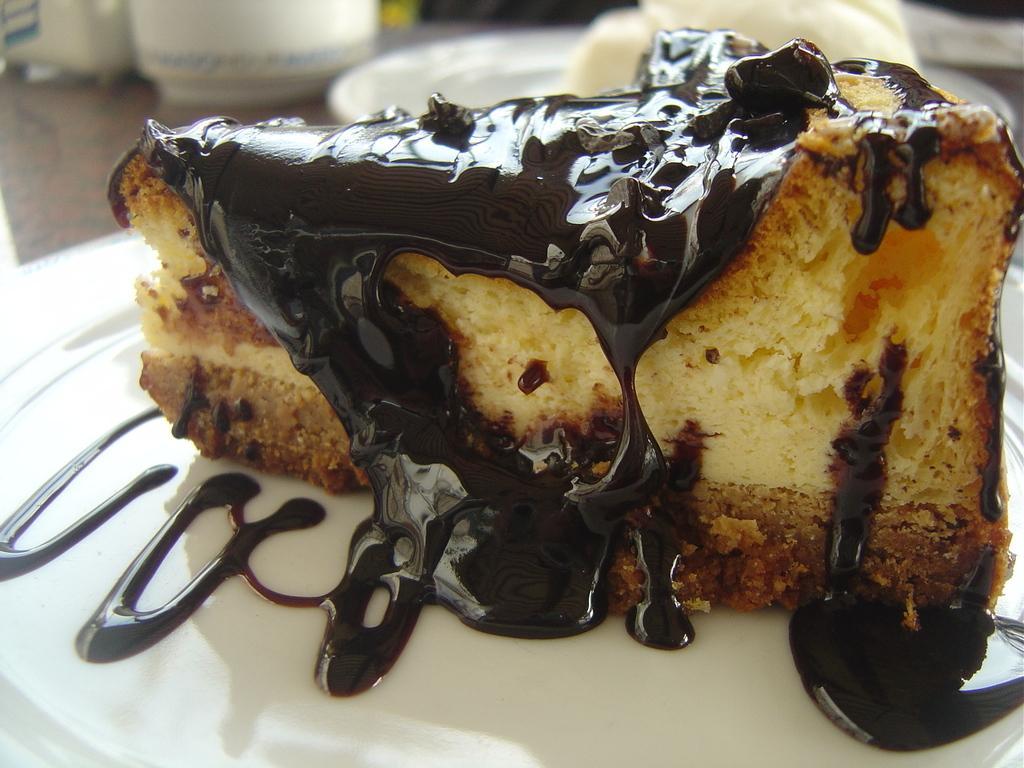Describe this image in one or two sentences. In this image we can see some food places in plates kept on the surface. In the background, we can see come bowls. 